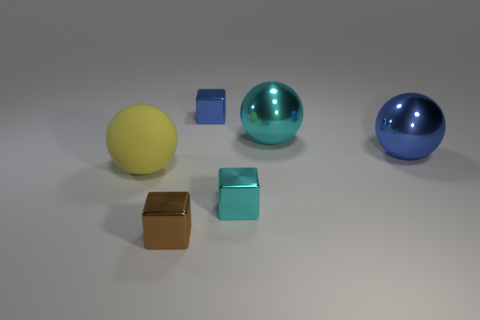How many objects are either small shiny objects behind the matte ball or small blue metal blocks?
Make the answer very short. 1. How many small cyan metallic objects are left of the tiny metallic block behind the yellow rubber object?
Give a very brief answer. 0. There is a blue thing that is behind the cyan object that is to the right of the cyan metallic thing that is in front of the rubber object; how big is it?
Provide a short and direct response. Small. The brown thing that is the same shape as the small blue thing is what size?
Your answer should be very brief. Small. What number of things are either metal cubes in front of the blue sphere or small cubes that are on the right side of the brown cube?
Your answer should be very brief. 3. There is a cyan metal object in front of the metallic ball that is to the right of the big cyan object; what is its shape?
Your answer should be very brief. Cube. Are there any other things of the same color as the large rubber sphere?
Offer a terse response. No. What number of things are yellow matte cylinders or blue spheres?
Make the answer very short. 1. Are there any other brown things that have the same size as the brown shiny object?
Your response must be concise. No. What shape is the small blue metallic thing?
Provide a short and direct response. Cube. 